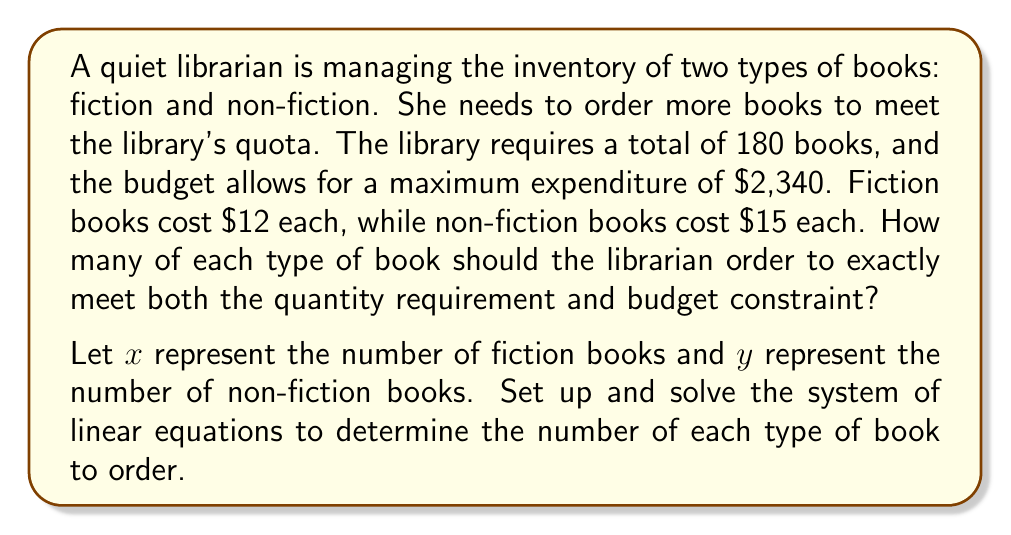Solve this math problem. Let's approach this step-by-step:

1) First, we need to set up our system of linear equations based on the given information:

   Equation 1 (Total books): $x + y = 180$
   Equation 2 (Budget constraint): $12x + 15y = 2340$

2) We can solve this system using the substitution method. Let's start by solving Equation 1 for $x$:

   $x = 180 - y$

3) Now, substitute this expression for $x$ into Equation 2:

   $12(180 - y) + 15y = 2340$

4) Simplify:

   $2160 - 12y + 15y = 2340$
   $2160 + 3y = 2340$

5) Subtract 2160 from both sides:

   $3y = 180$

6) Divide both sides by 3:

   $y = 60$

7) Now that we know $y$, we can substitute this value back into the equation from step 2 to find $x$:

   $x = 180 - y = 180 - 60 = 120$

8) Let's verify our solution satisfies both original equations:

   Equation 1: $120 + 60 = 180$ ✓
   Equation 2: $12(120) + 15(60) = 1440 + 900 = 2340$ ✓

Therefore, the librarian should order 120 fiction books and 60 non-fiction books.
Answer: The librarian should order 120 fiction books and 60 non-fiction books. 